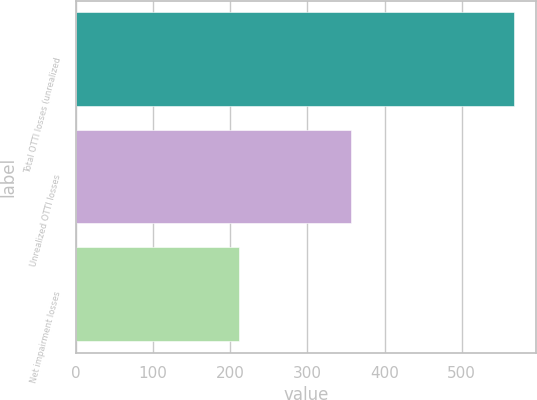Convert chart to OTSL. <chart><loc_0><loc_0><loc_500><loc_500><bar_chart><fcel>Total OTTI losses (unrealized<fcel>Unrealized OTTI losses<fcel>Net impairment losses<nl><fcel>568<fcel>357<fcel>211<nl></chart> 